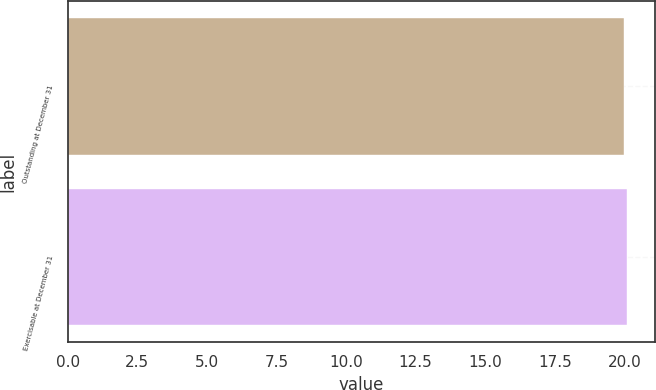Convert chart to OTSL. <chart><loc_0><loc_0><loc_500><loc_500><bar_chart><fcel>Outstanding at December 31<fcel>Exercisable at December 31<nl><fcel>20<fcel>20.1<nl></chart> 